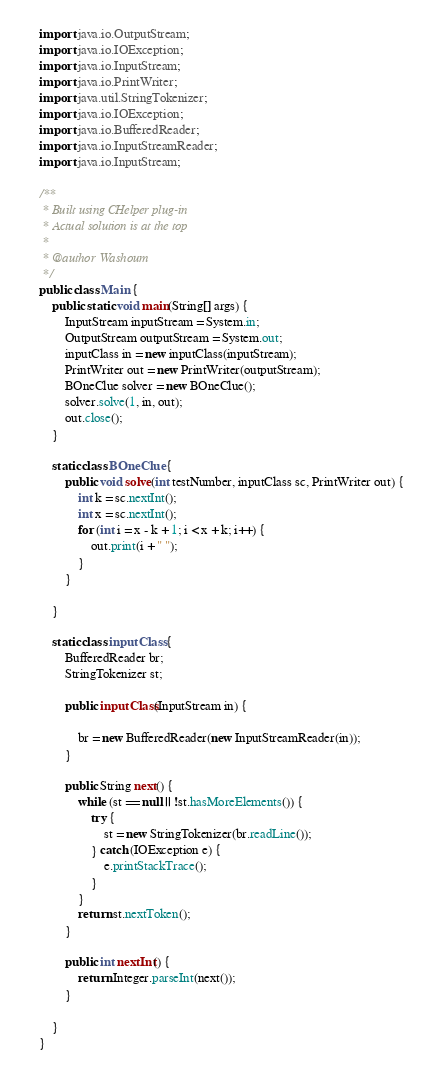Convert code to text. <code><loc_0><loc_0><loc_500><loc_500><_Java_>import java.io.OutputStream;
import java.io.IOException;
import java.io.InputStream;
import java.io.PrintWriter;
import java.util.StringTokenizer;
import java.io.IOException;
import java.io.BufferedReader;
import java.io.InputStreamReader;
import java.io.InputStream;

/**
 * Built using CHelper plug-in
 * Actual solution is at the top
 *
 * @author Washoum
 */
public class Main {
    public static void main(String[] args) {
        InputStream inputStream = System.in;
        OutputStream outputStream = System.out;
        inputClass in = new inputClass(inputStream);
        PrintWriter out = new PrintWriter(outputStream);
        BOneClue solver = new BOneClue();
        solver.solve(1, in, out);
        out.close();
    }

    static class BOneClue {
        public void solve(int testNumber, inputClass sc, PrintWriter out) {
            int k = sc.nextInt();
            int x = sc.nextInt();
            for (int i = x - k + 1; i < x + k; i++) {
                out.print(i + " ");
            }
        }

    }

    static class inputClass {
        BufferedReader br;
        StringTokenizer st;

        public inputClass(InputStream in) {

            br = new BufferedReader(new InputStreamReader(in));
        }

        public String next() {
            while (st == null || !st.hasMoreElements()) {
                try {
                    st = new StringTokenizer(br.readLine());
                } catch (IOException e) {
                    e.printStackTrace();
                }
            }
            return st.nextToken();
        }

        public int nextInt() {
            return Integer.parseInt(next());
        }

    }
}

</code> 